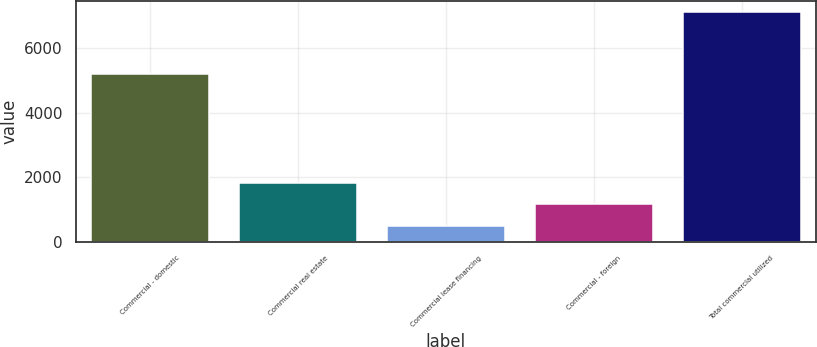<chart> <loc_0><loc_0><loc_500><loc_500><bar_chart><fcel>Commercial - domestic<fcel>Commercial real estate<fcel>Commercial lease financing<fcel>Commercial - foreign<fcel>Total commercial utilized<nl><fcel>5210<fcel>1825.4<fcel>504<fcel>1164.7<fcel>7111<nl></chart> 